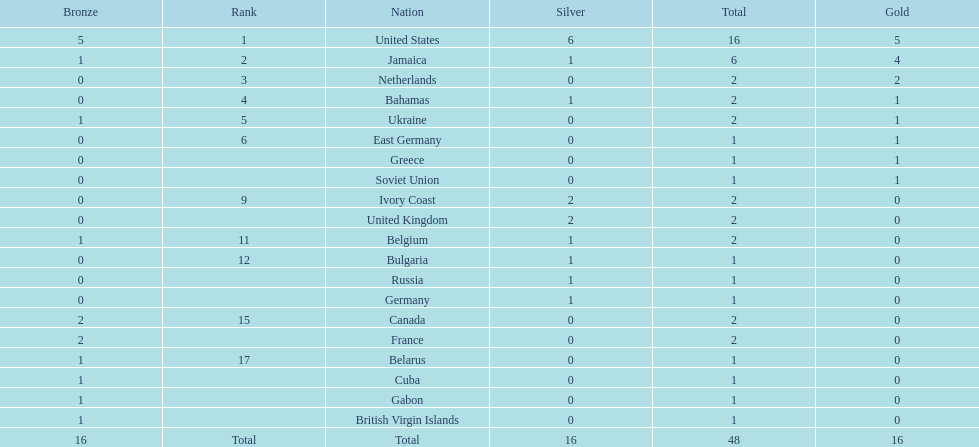In which country did the most gold medals get won? United States. 